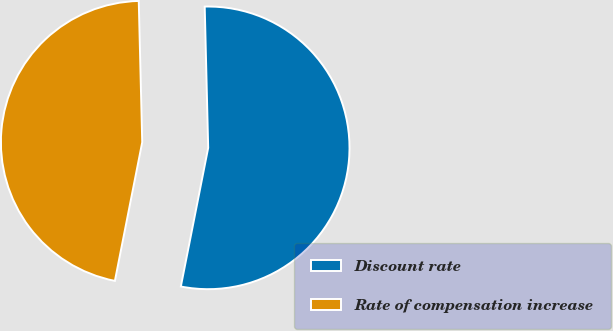<chart> <loc_0><loc_0><loc_500><loc_500><pie_chart><fcel>Discount rate<fcel>Rate of compensation increase<nl><fcel>53.49%<fcel>46.51%<nl></chart> 